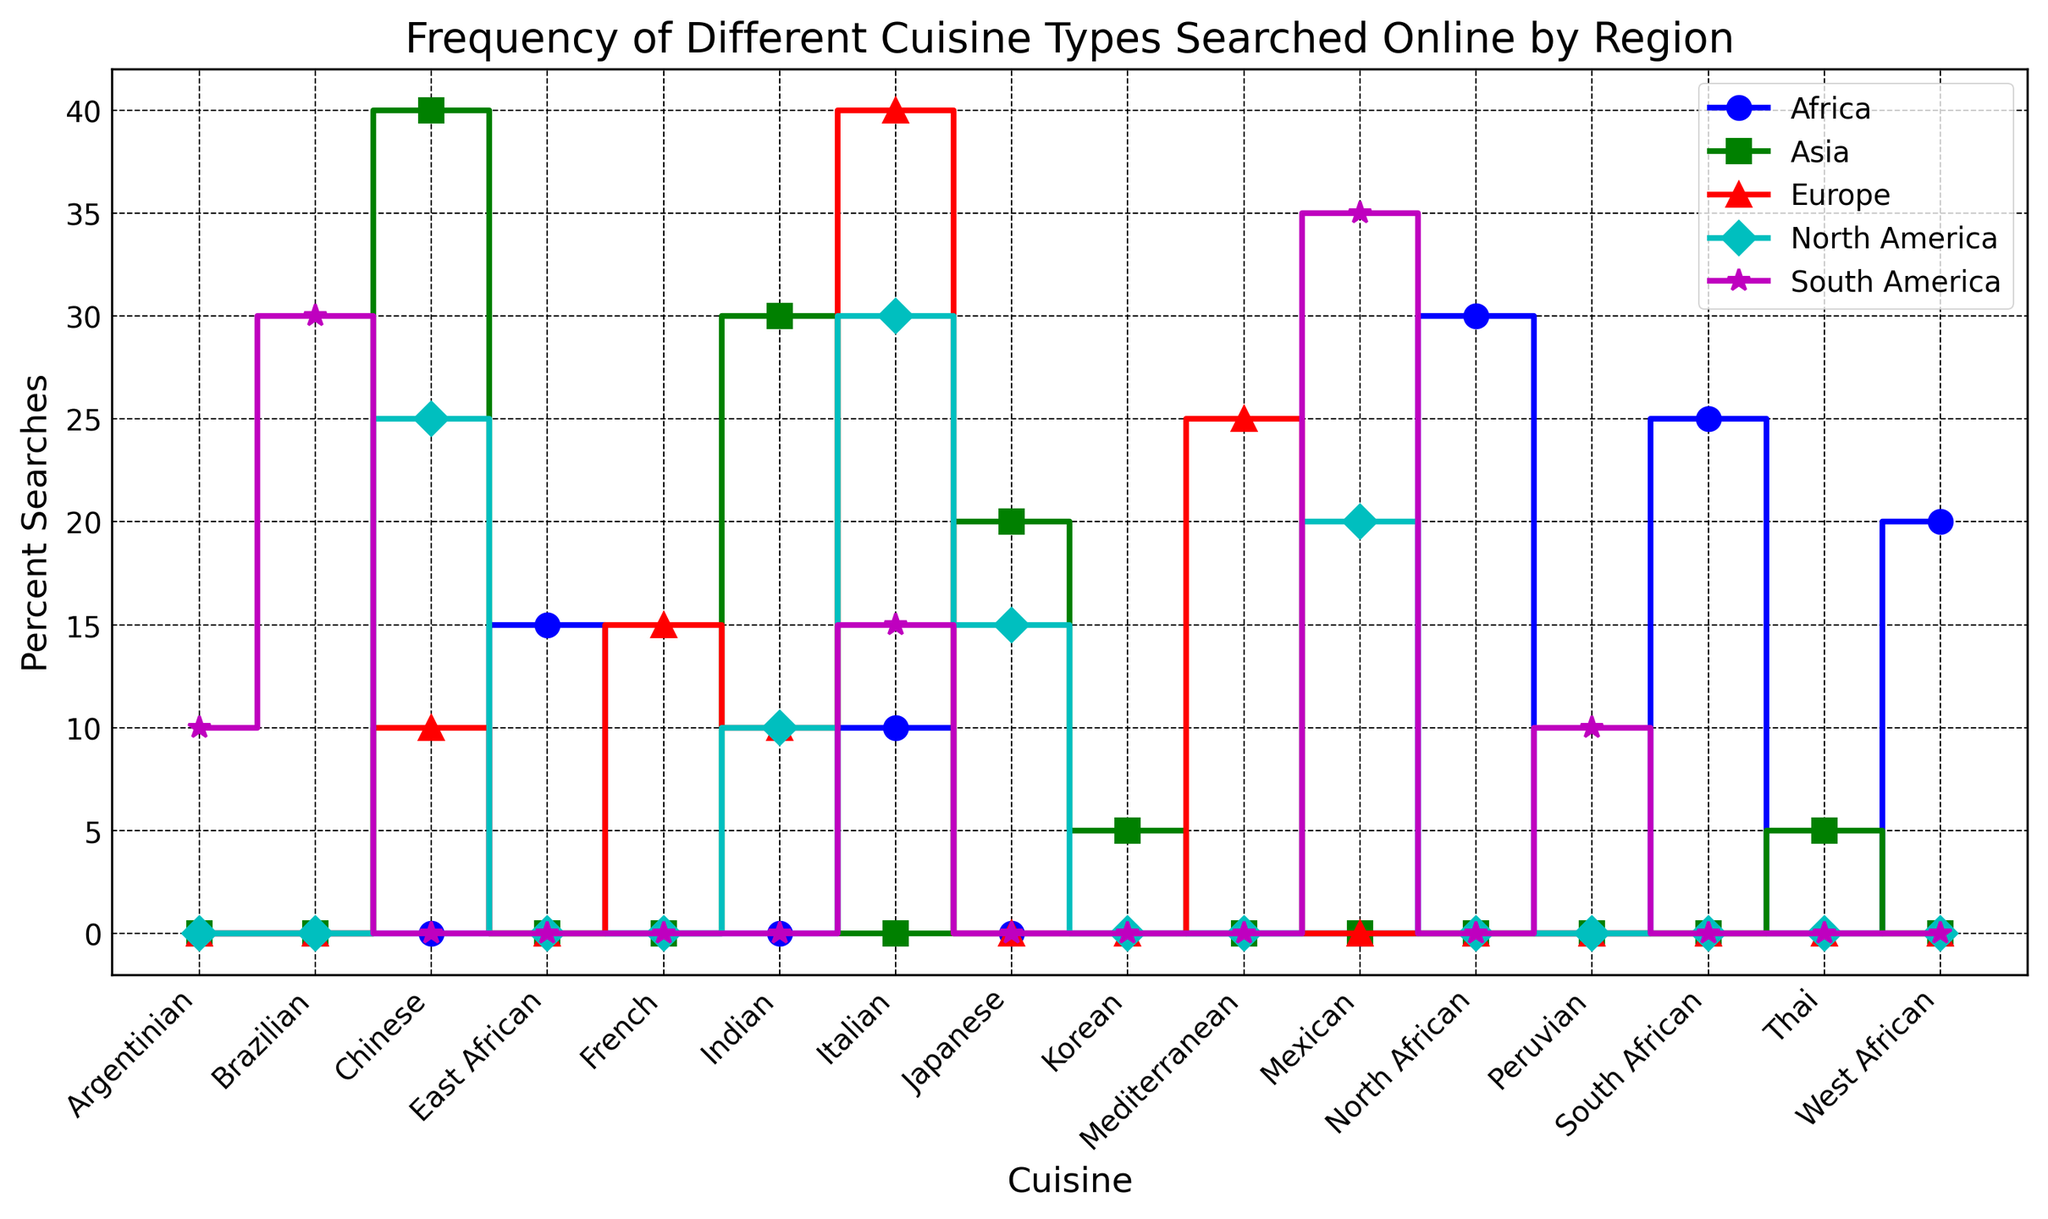Which region has the highest percentage of searches for Italian cuisine? Look at the steps plotted for Italian cuisine across all regions. The highest point corresponds to Europe with 40%.
Answer: Europe What is the combined percentage of searches for Chinese and Indian cuisines in North America? Locate the steps for North America related to Chinese and Indian cuisines. Chinese is at 25% and Indian is at 10%, summing up to a total of 35%.
Answer: 35% Which cuisine has a consistent percentage of searches (10%) across multiple regions? Verify the steps for each cuisine across all regions, identifying any cuisine that consistently appears at 10%. Indian cuisine is listed as 10% in both North America and Europe.
Answer: Indian Compare the popularity of Mexican cuisine between North America and South America. Which region has a higher percentage? Observe the steps for Mexican cuisine in North America and South America. North America has it at 20%, while South America has it at 35%. Clearly, South America has a higher percentage.
Answer: South America What is the difference in the search percentage for Japanese cuisine between North America and Asia? Check the steps for Japanese cuisine in North America (15%) and Asia (20%), then calculate the difference, which is 20% - 15% = 5%.
Answer: 5% Identify the region with the highest percentage of cuisine search for African cuisines overall. Examine steps related to all African cuisines across different regions. Africa shows North African (30%), West African (20%), East African (15%), and South African (25%), making it the region with the highest percentages for African cuisines.
Answer: Africa What's the average search percentage for Italian cuisine across all regions? Sum up the search percentages for Italian cuisine in North America (30%), Europe (40%), South America (15%), and Africa (10%), and then divide by the number of regions: (30 + 40 + 15 + 10) / 4 = 95 / 4 = 23.75%.
Answer: 23.75% Which cuisine is the least searched in Asia? Check the steps for various cuisines in Asia. The least searched cuisines are Thai and Korean, both at 5%.
Answer: Thai and Korean How does the popularity of South African cuisine in Africa compare with that of Brazilian cuisine in South America? Look at the steps corresponding to South African cuisine in Africa, which is 25%, and Brazilian cuisine in South America, which is 30%. Brazilian cuisine is more searched.
Answer: Brazilian What is the second most searched cuisine in Europe? Identify the steps in Europe, where Italian is the highest (40%), followed by Mediterranean cuisine at 25%, which is the second highest.
Answer: Mediterranean 